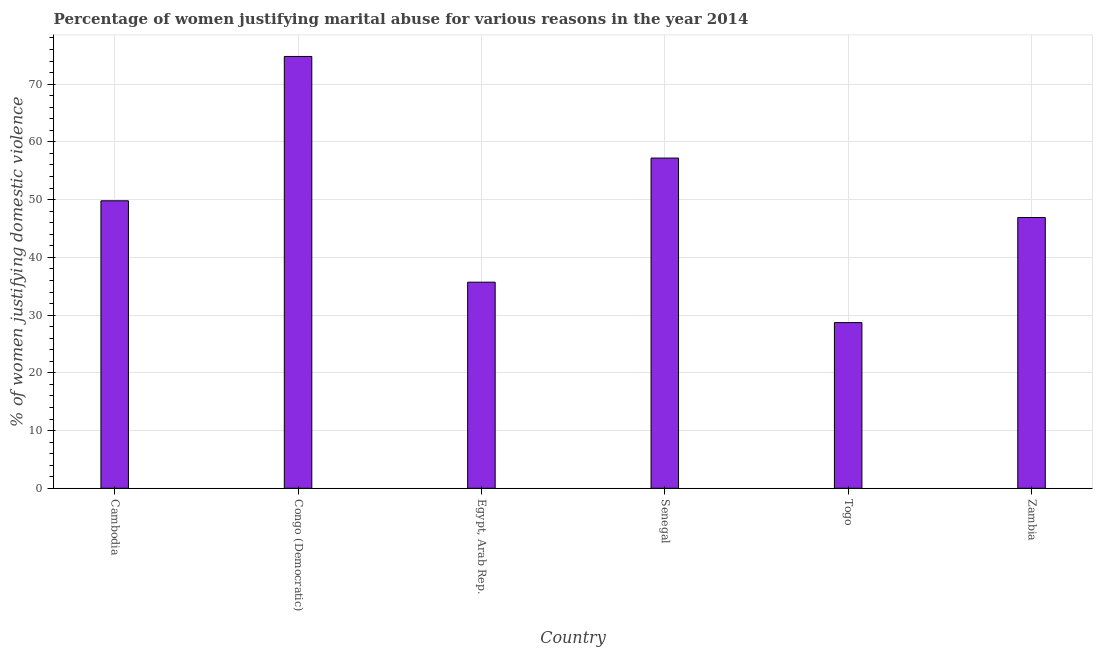Does the graph contain any zero values?
Your answer should be compact. No. Does the graph contain grids?
Your response must be concise. Yes. What is the title of the graph?
Offer a terse response. Percentage of women justifying marital abuse for various reasons in the year 2014. What is the label or title of the X-axis?
Your answer should be very brief. Country. What is the label or title of the Y-axis?
Provide a short and direct response. % of women justifying domestic violence. What is the percentage of women justifying marital abuse in Cambodia?
Give a very brief answer. 49.8. Across all countries, what is the maximum percentage of women justifying marital abuse?
Offer a very short reply. 74.8. Across all countries, what is the minimum percentage of women justifying marital abuse?
Give a very brief answer. 28.7. In which country was the percentage of women justifying marital abuse maximum?
Your response must be concise. Congo (Democratic). In which country was the percentage of women justifying marital abuse minimum?
Your response must be concise. Togo. What is the sum of the percentage of women justifying marital abuse?
Provide a short and direct response. 293.1. What is the average percentage of women justifying marital abuse per country?
Your answer should be compact. 48.85. What is the median percentage of women justifying marital abuse?
Provide a short and direct response. 48.35. What is the ratio of the percentage of women justifying marital abuse in Senegal to that in Togo?
Your answer should be compact. 1.99. Is the percentage of women justifying marital abuse in Cambodia less than that in Togo?
Make the answer very short. No. Is the difference between the percentage of women justifying marital abuse in Congo (Democratic) and Zambia greater than the difference between any two countries?
Keep it short and to the point. No. What is the difference between the highest and the second highest percentage of women justifying marital abuse?
Keep it short and to the point. 17.6. Is the sum of the percentage of women justifying marital abuse in Egypt, Arab Rep. and Togo greater than the maximum percentage of women justifying marital abuse across all countries?
Provide a short and direct response. No. What is the difference between the highest and the lowest percentage of women justifying marital abuse?
Your answer should be compact. 46.1. Are all the bars in the graph horizontal?
Offer a terse response. No. How many countries are there in the graph?
Keep it short and to the point. 6. What is the difference between two consecutive major ticks on the Y-axis?
Offer a terse response. 10. Are the values on the major ticks of Y-axis written in scientific E-notation?
Give a very brief answer. No. What is the % of women justifying domestic violence of Cambodia?
Give a very brief answer. 49.8. What is the % of women justifying domestic violence of Congo (Democratic)?
Provide a short and direct response. 74.8. What is the % of women justifying domestic violence of Egypt, Arab Rep.?
Provide a short and direct response. 35.7. What is the % of women justifying domestic violence of Senegal?
Your answer should be compact. 57.2. What is the % of women justifying domestic violence in Togo?
Ensure brevity in your answer.  28.7. What is the % of women justifying domestic violence of Zambia?
Offer a terse response. 46.9. What is the difference between the % of women justifying domestic violence in Cambodia and Egypt, Arab Rep.?
Provide a short and direct response. 14.1. What is the difference between the % of women justifying domestic violence in Cambodia and Senegal?
Ensure brevity in your answer.  -7.4. What is the difference between the % of women justifying domestic violence in Cambodia and Togo?
Make the answer very short. 21.1. What is the difference between the % of women justifying domestic violence in Congo (Democratic) and Egypt, Arab Rep.?
Provide a succinct answer. 39.1. What is the difference between the % of women justifying domestic violence in Congo (Democratic) and Togo?
Your answer should be very brief. 46.1. What is the difference between the % of women justifying domestic violence in Congo (Democratic) and Zambia?
Your answer should be very brief. 27.9. What is the difference between the % of women justifying domestic violence in Egypt, Arab Rep. and Senegal?
Make the answer very short. -21.5. What is the difference between the % of women justifying domestic violence in Egypt, Arab Rep. and Zambia?
Give a very brief answer. -11.2. What is the difference between the % of women justifying domestic violence in Senegal and Togo?
Offer a terse response. 28.5. What is the difference between the % of women justifying domestic violence in Togo and Zambia?
Keep it short and to the point. -18.2. What is the ratio of the % of women justifying domestic violence in Cambodia to that in Congo (Democratic)?
Keep it short and to the point. 0.67. What is the ratio of the % of women justifying domestic violence in Cambodia to that in Egypt, Arab Rep.?
Ensure brevity in your answer.  1.4. What is the ratio of the % of women justifying domestic violence in Cambodia to that in Senegal?
Offer a very short reply. 0.87. What is the ratio of the % of women justifying domestic violence in Cambodia to that in Togo?
Make the answer very short. 1.74. What is the ratio of the % of women justifying domestic violence in Cambodia to that in Zambia?
Provide a short and direct response. 1.06. What is the ratio of the % of women justifying domestic violence in Congo (Democratic) to that in Egypt, Arab Rep.?
Your answer should be compact. 2.1. What is the ratio of the % of women justifying domestic violence in Congo (Democratic) to that in Senegal?
Offer a terse response. 1.31. What is the ratio of the % of women justifying domestic violence in Congo (Democratic) to that in Togo?
Keep it short and to the point. 2.61. What is the ratio of the % of women justifying domestic violence in Congo (Democratic) to that in Zambia?
Give a very brief answer. 1.59. What is the ratio of the % of women justifying domestic violence in Egypt, Arab Rep. to that in Senegal?
Provide a succinct answer. 0.62. What is the ratio of the % of women justifying domestic violence in Egypt, Arab Rep. to that in Togo?
Give a very brief answer. 1.24. What is the ratio of the % of women justifying domestic violence in Egypt, Arab Rep. to that in Zambia?
Your answer should be compact. 0.76. What is the ratio of the % of women justifying domestic violence in Senegal to that in Togo?
Provide a short and direct response. 1.99. What is the ratio of the % of women justifying domestic violence in Senegal to that in Zambia?
Provide a succinct answer. 1.22. What is the ratio of the % of women justifying domestic violence in Togo to that in Zambia?
Give a very brief answer. 0.61. 